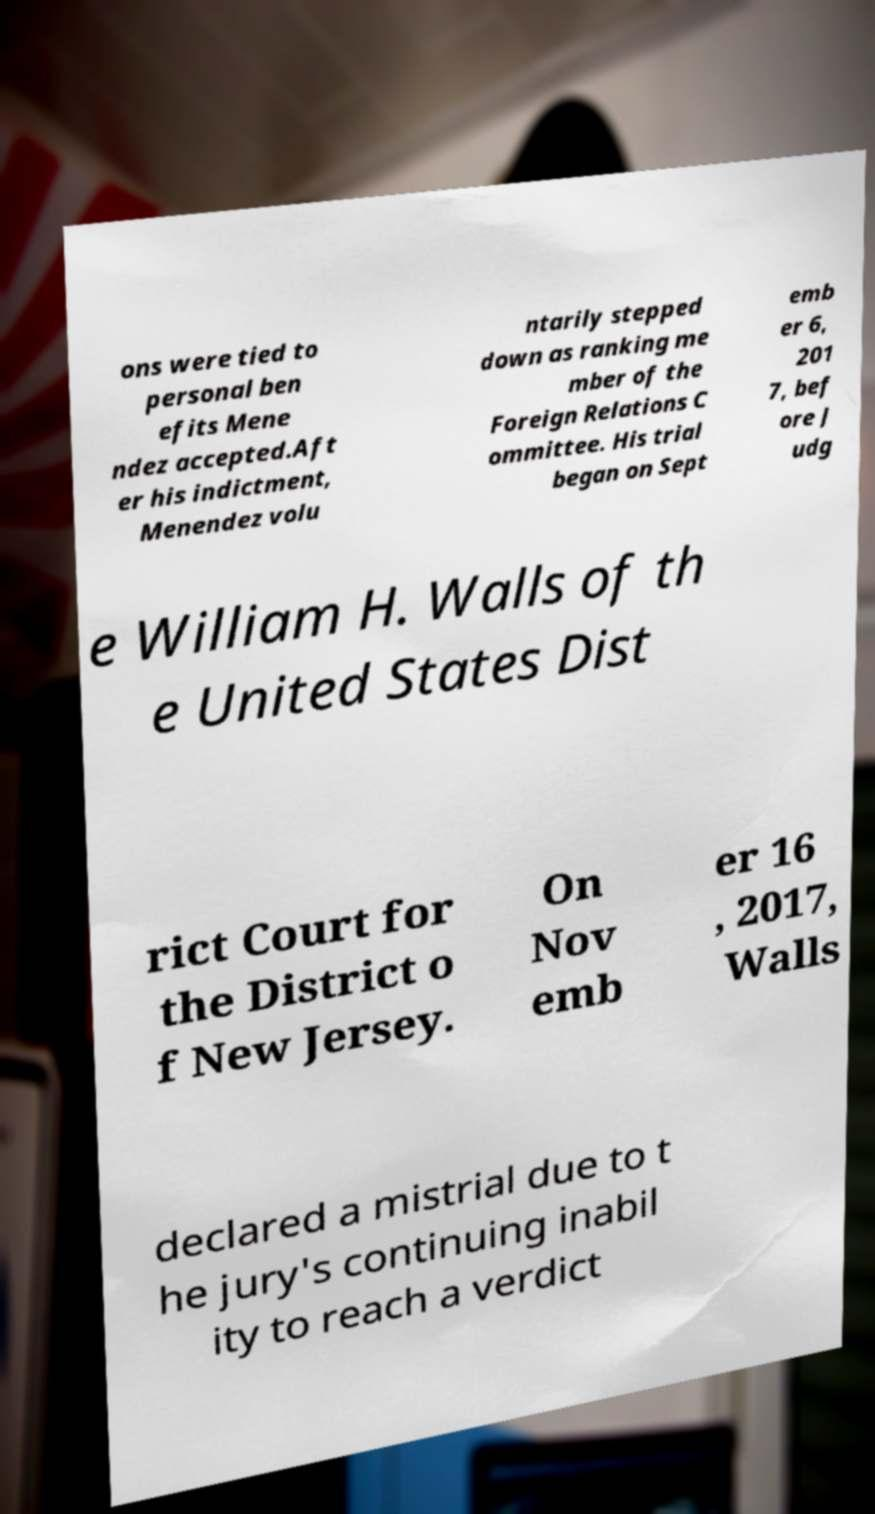There's text embedded in this image that I need extracted. Can you transcribe it verbatim? ons were tied to personal ben efits Mene ndez accepted.Aft er his indictment, Menendez volu ntarily stepped down as ranking me mber of the Foreign Relations C ommittee. His trial began on Sept emb er 6, 201 7, bef ore J udg e William H. Walls of th e United States Dist rict Court for the District o f New Jersey. On Nov emb er 16 , 2017, Walls declared a mistrial due to t he jury's continuing inabil ity to reach a verdict 